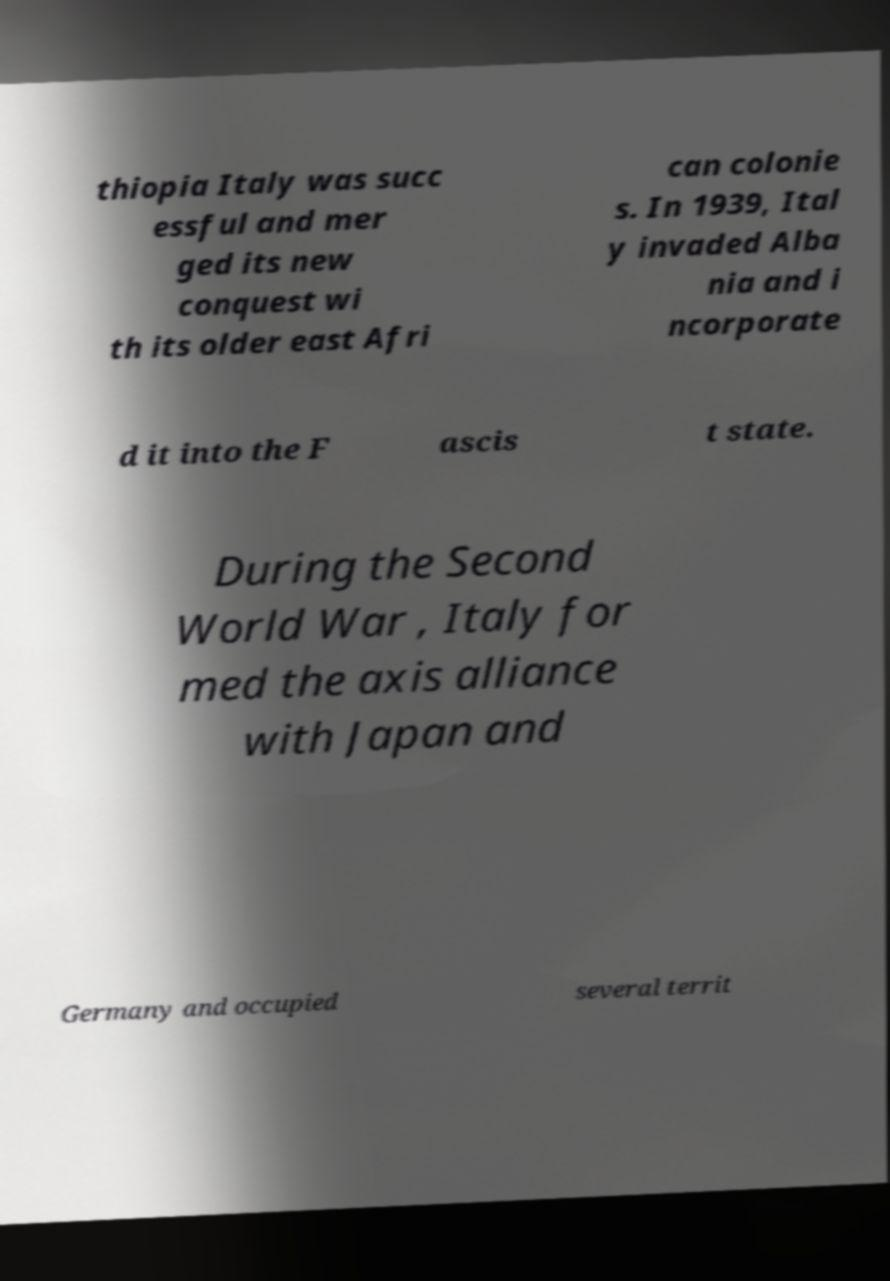Please read and relay the text visible in this image. What does it say? thiopia Italy was succ essful and mer ged its new conquest wi th its older east Afri can colonie s. In 1939, Ital y invaded Alba nia and i ncorporate d it into the F ascis t state. During the Second World War , Italy for med the axis alliance with Japan and Germany and occupied several territ 